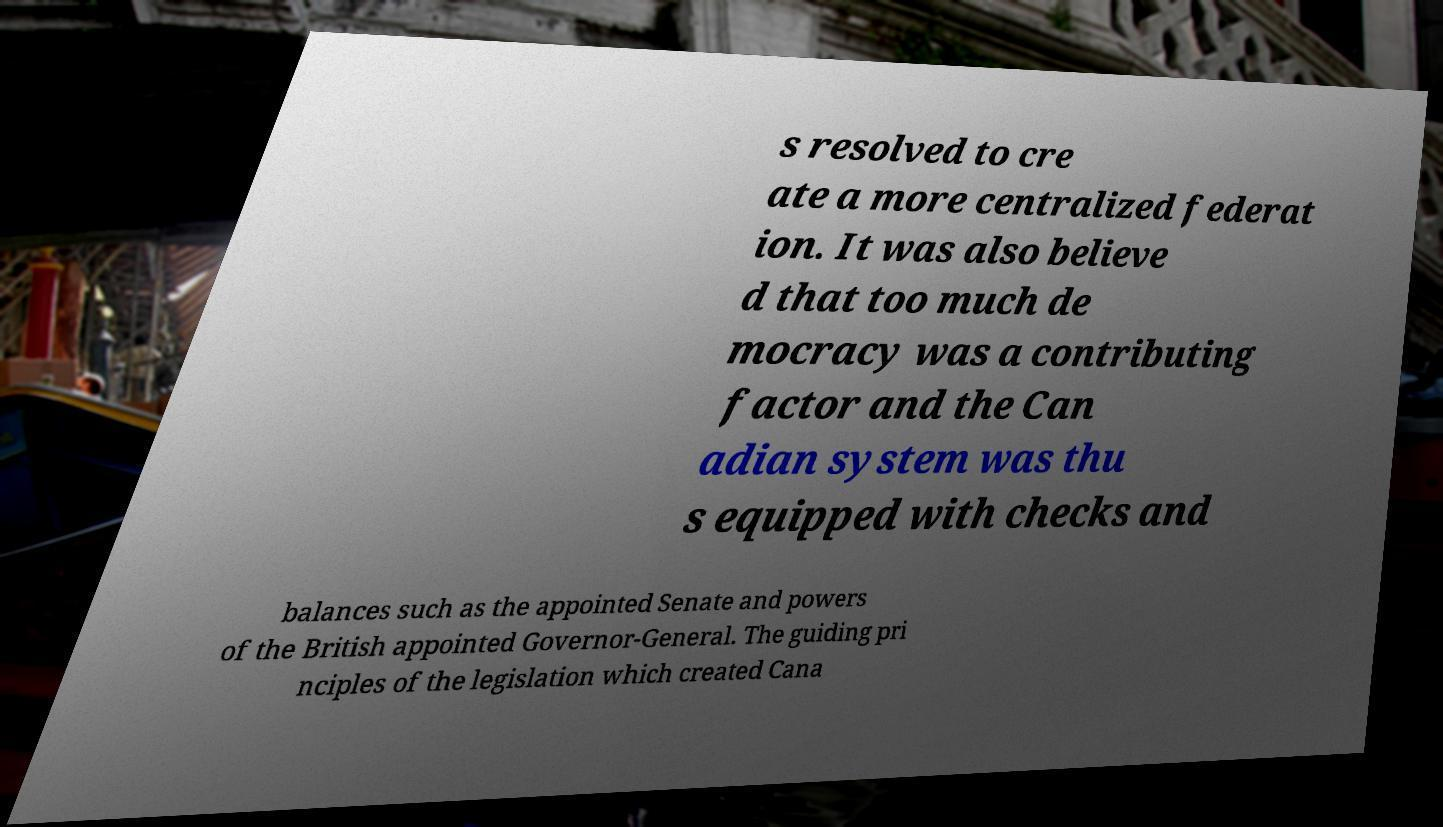Please read and relay the text visible in this image. What does it say? s resolved to cre ate a more centralized federat ion. It was also believe d that too much de mocracy was a contributing factor and the Can adian system was thu s equipped with checks and balances such as the appointed Senate and powers of the British appointed Governor-General. The guiding pri nciples of the legislation which created Cana 